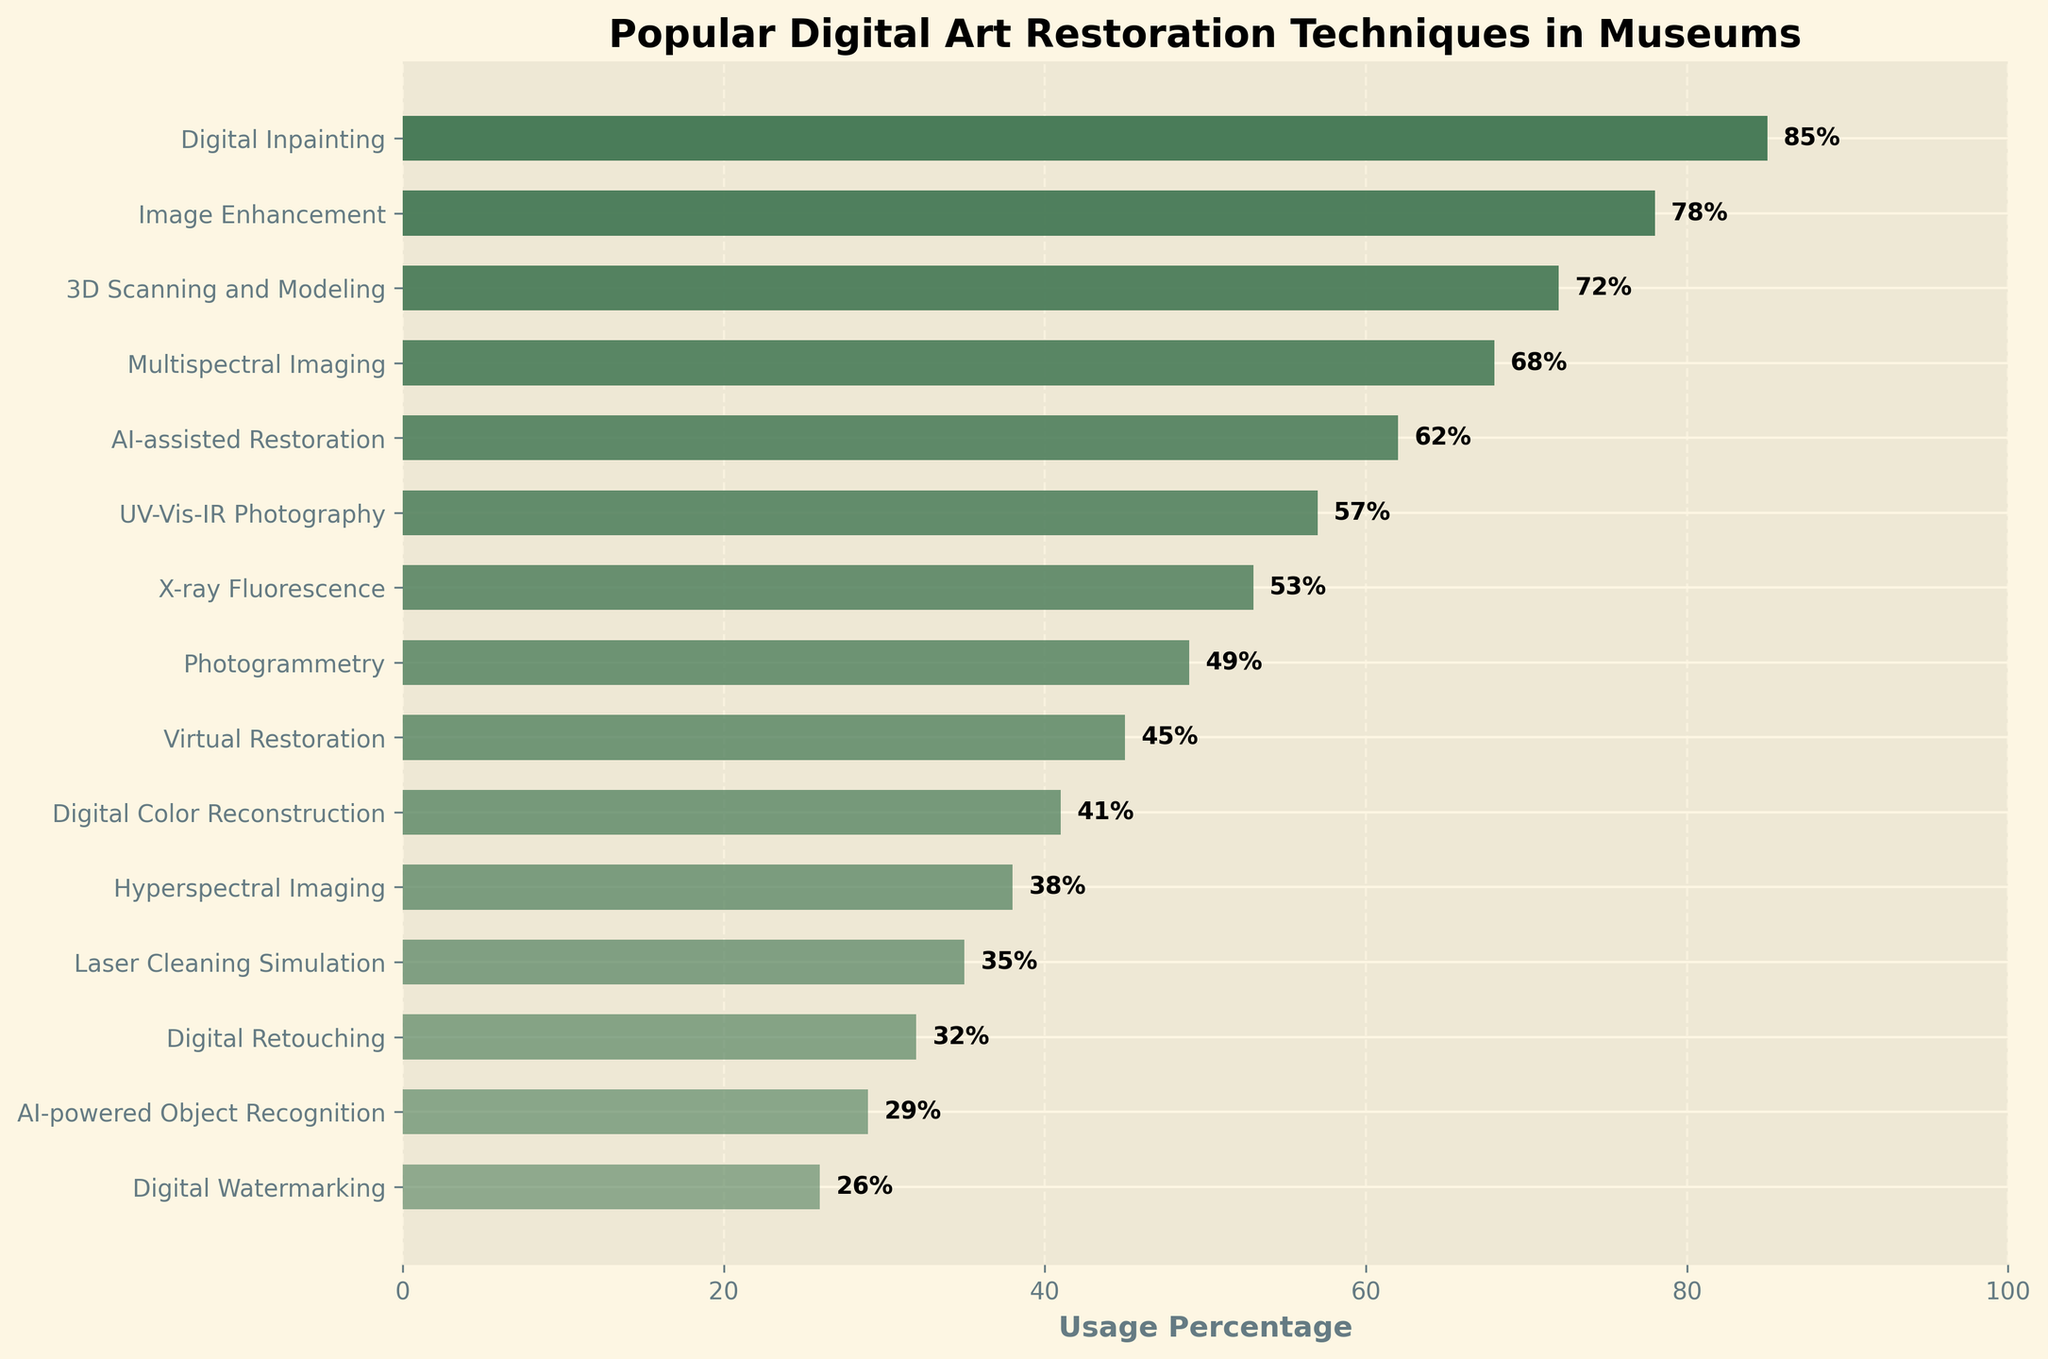What is the most popular digital art restoration technique? The highest value on the bar chart corresponds to the technique "Digital Inpainting" with a usage percentage of 85%.
Answer: Digital Inpainting What is the difference in usage percentage between "Digital Inpainting" and "Digital Watermarking"? The usage percentage for "Digital Inpainting" is 85%, and for "Digital Watermarking", it is 26%. Hence, the difference is 85% - 26% = 59%.
Answer: 59% Which technique has a higher usage percentage: "AI-assisted Restoration" or "Laser Cleaning Simulation"? "AI-assisted Restoration" has a usage percentage of 62%, while "Laser Cleaning Simulation" has 35%. Therefore, "AI-assisted Restoration" has a higher usage percentage.
Answer: AI-assisted Restoration What is the combined usage percentage of the top three techniques? The top three techniques are "Digital Inpainting" (85%), "Image Enhancement" (78%), and "3D Scanning and Modeling" (72%). Their combined usage percentage is 85% + 78% + 72% = 235%.
Answer: 235% Among the listed techniques, which one has the lowest usage percentage? The lowest bar corresponds to "Digital Watermarking" with a usage percentage of 26%.
Answer: Digital Watermarking What is the average usage percentage of "Multispectral Imaging", "UV-Vis-IR Photography", and "X-ray Fluorescence"? The usage percentages are 68%, 57%, and 53%, respectively. The average is (68% + 57% + 53%) / 3 = 59.33%.
Answer: 59.33% Which technique has exactly a 50% less usage percentage than "Digital Inpainting"? "Digital Inpainting" has a usage percentage of 85%, half of which is 42.5%. The closest technique is "Digital Color Reconstruction" with 41%.
Answer: Digital Color Reconstruction How many techniques have a usage percentage greater than 50%? Techniques with more than 50% usage are "Digital Inpainting", "Image Enhancement", "3D Scanning and Modeling", "Multispectral Imaging", "AI-assisted Restoration", "UV-Vis-IR Photography", and "X-ray Fluorescence". Counting them gives a total of 7 techniques.
Answer: 7 By how much does "3D Scanning and Modeling" exceed the usage percentage of "AI-powered Object Recognition"? "3D Scanning and Modeling" has a usage percentage of 72%, and "AI-powered Object Recognition" has 29%. The difference is 72% - 29% = 43%.
Answer: 43% What is the second least popular technique? The second lowest bar corresponds to "AI-powered Object Recognition" with a usage percentage of 29%.
Answer: AI-powered Object Recognition 